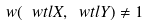<formula> <loc_0><loc_0><loc_500><loc_500>w ( \ w t l X , \ w t l Y ) \ne 1</formula> 